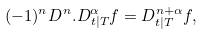Convert formula to latex. <formula><loc_0><loc_0><loc_500><loc_500>( - 1 ) ^ { n } D ^ { n } . D ^ { \alpha } _ { t | T } f = D ^ { n + \alpha } _ { t | T } f ,</formula> 